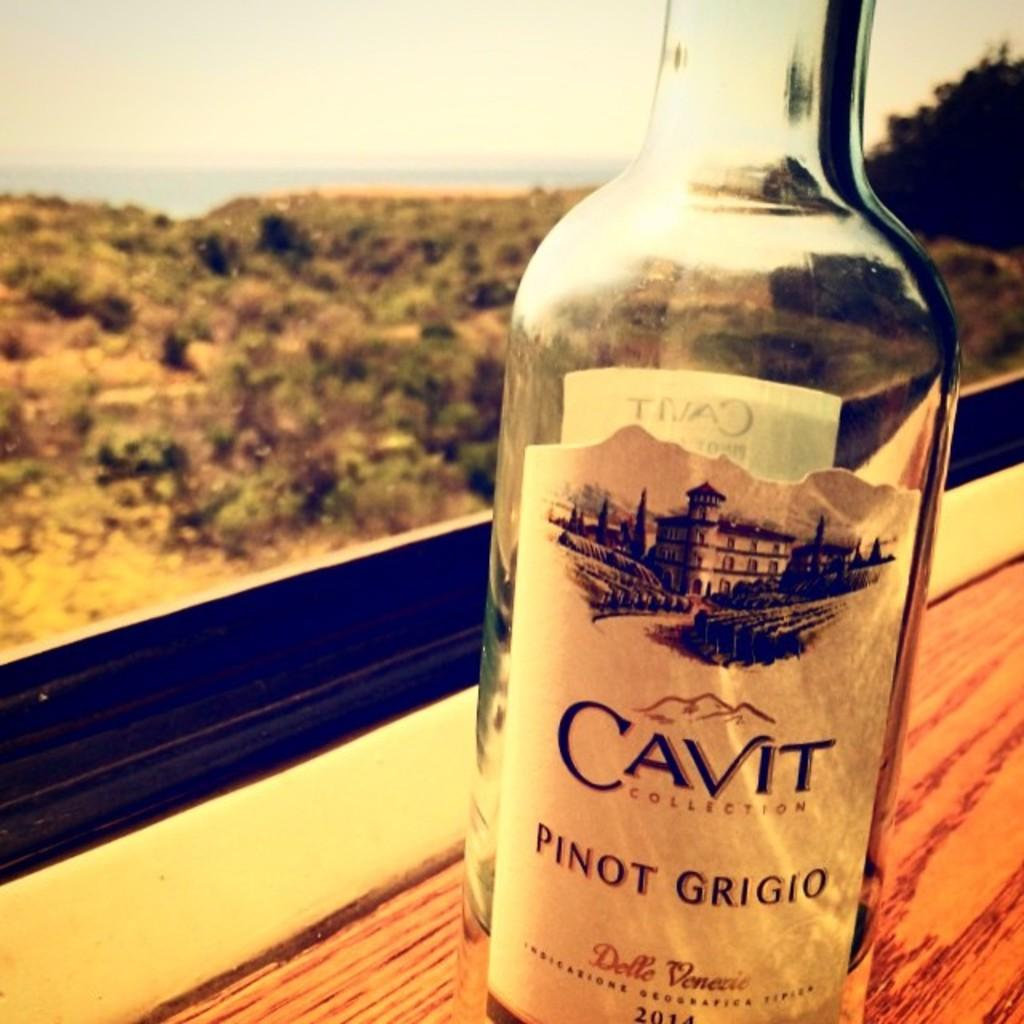<image>
Summarize the visual content of the image. A near empty bottle of Cavit Pinot Grigio sits on a window ledge 